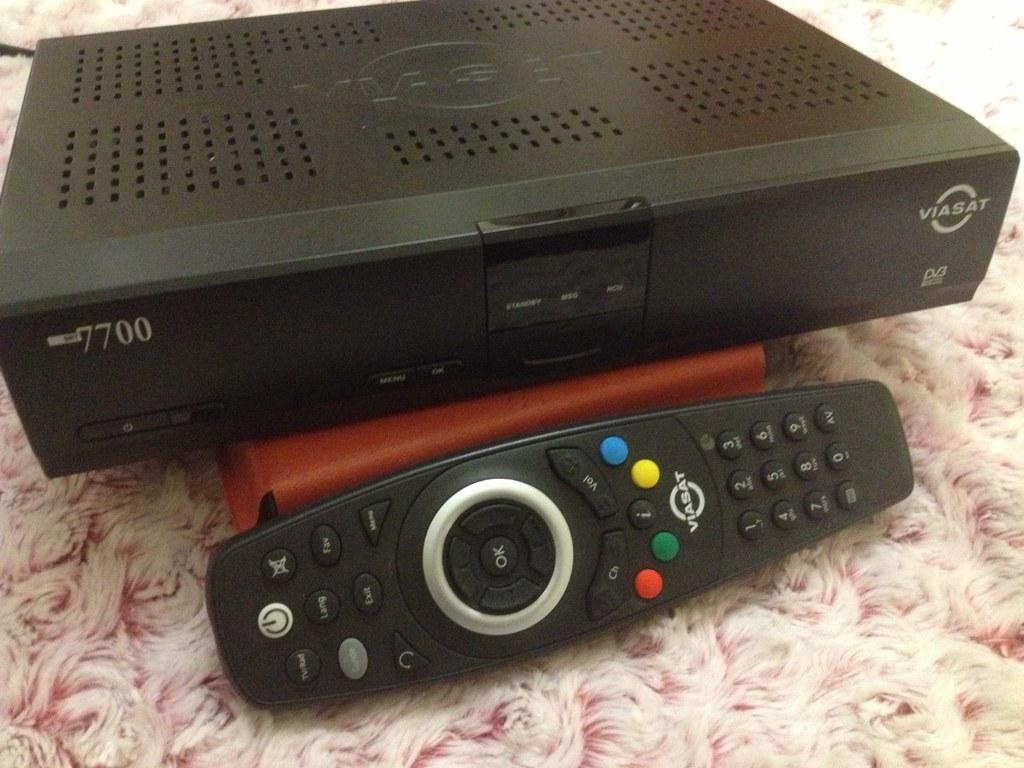<image>
Give a short and clear explanation of the subsequent image. A Viasat Cable Box sits behind a Viasat remote control on a table. 